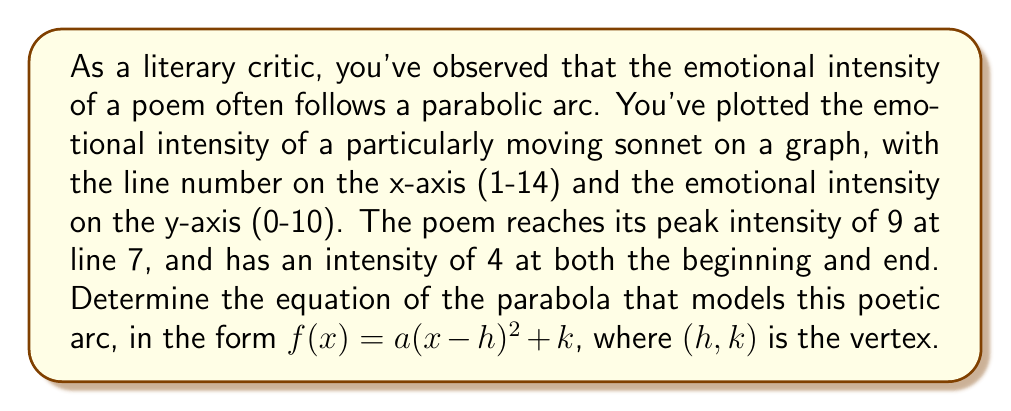Solve this math problem. 1) First, we identify the vertex of the parabola. The peak intensity occurs at line 7, with an intensity of 9. So, the vertex is (7, 9).

2) We can now write our equation in the form:
   $f(x) = a(x-7)^2 + 9$

3) To find $a$, we can use either the first or last point, as both have an intensity of 4. Let's use (1, 4):

   $4 = a(1-7)^2 + 9$
   $4 = a(36) + 9$
   $-5 = 36a$
   $a = -\frac{5}{36}$

4) Therefore, our equation is:
   $f(x) = -\frac{5}{36}(x-7)^2 + 9$

5) To verify, we can check the other point (14, 4):
   $f(14) = -\frac{5}{36}(14-7)^2 + 9$
          $= -\frac{5}{36}(49) + 9$
          $= -\frac{245}{36} + 9$
          $= -\frac{245}{36} + \frac{324}{36}$
          $= \frac{79}{36} \approx 4$

   This confirms our equation is correct.
Answer: $f(x) = -\frac{5}{36}(x-7)^2 + 9$ 